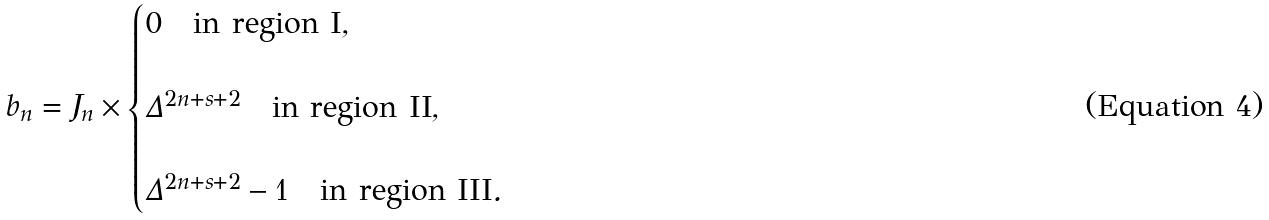<formula> <loc_0><loc_0><loc_500><loc_500>b _ { n } = J _ { n } \times \begin{cases} 0 \quad \text {in region I} , \\ \\ \Delta ^ { 2 n + s + 2 } \quad \text {in region II} , \\ \\ \Delta ^ { 2 n + s + 2 } - 1 \quad \text {in region III} . \end{cases}</formula> 